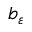<formula> <loc_0><loc_0><loc_500><loc_500>b _ { \varepsilon }</formula> 